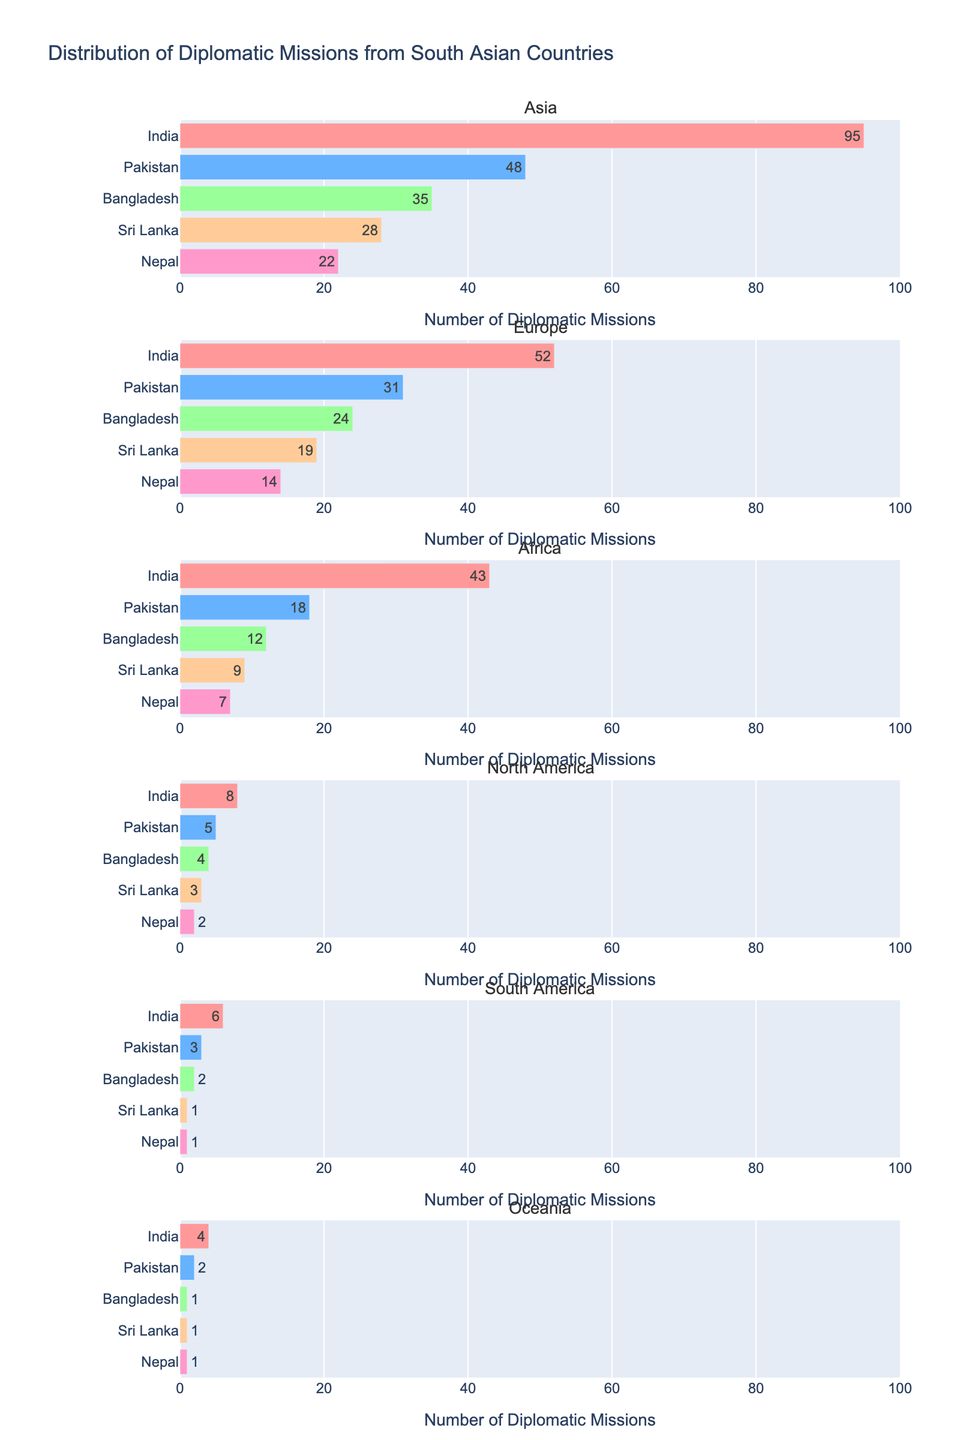What is the title of the figure? The title of a figure is usually positioned at the top and provides an overview of the content. Here, the title summarizes the main topic addressed by the plot.
Answer: Distribution of Diplomatic Missions from South Asian Countries How many diplomatic missions does India have in Europe? To find this, look at the subplot titled "Europe" and find the bar labeled "India." The text within the bar indicates the number of diplomatic missions.
Answer: 52 Which South Asian country has the fewest diplomatic missions in Oceania? To determine this, look at the subplot for "Oceania" and compare the heights and text of the bars for all countries. The smallest value identifies the country with the fewest missions.
Answer: Bangladesh, Sri Lanka, Nepal (all have 1) How many total diplomatic missions does Pakistan have across all continents? Add the number of missions in each subplot labeled "Pakistan" to get the total. Calculate as follows: 48 (Asia) + 31 (Europe) + 18 (Africa) + 5 (North America) + 3 (South America) + 2 (Oceania).
Answer: 107 Which continent has the highest number of diplomatic missions from Bangladesh? Look at the subplots for all continents and find where the bar for Bangladesh is the highest/has the largest numerical value.
Answer: Asia Which country has the most diplomatic missions in Asia? Look at the "Asia" subplot and compare the lengths and texts of the bars for all countries. The one with the highest value has the most missions.
Answer: India (95) How does the distribution of diplomatic missions for Nepal change across different continents? Observe and explain the values for Nepal in each subplot (Asia, Europe, Africa, North America, South America, Oceania): Asia: 22, Europe: 14, Africa: 7, North America: 2, South America: 1, Oceania: 1. Nepal has the most missions in Asia and the least in South America and Oceania.
Answer: It decreases moving from Asia to Europe, Africa, North America, South America, and Oceania 